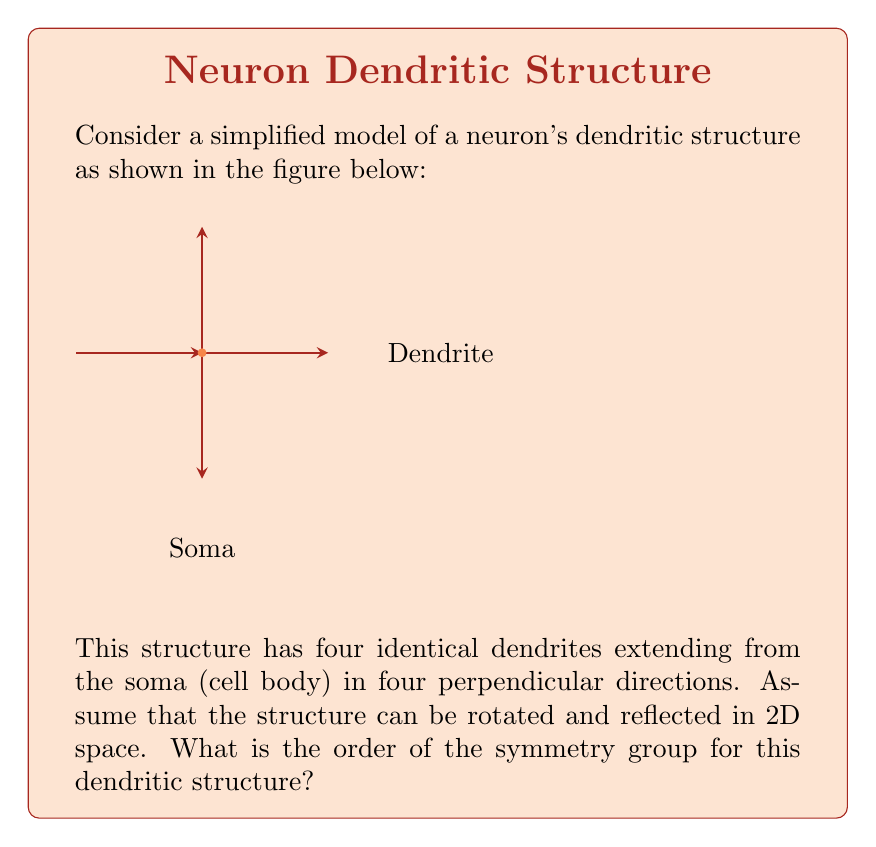Can you solve this math problem? To analyze the symmetry group of this dendritic structure, we need to consider all possible transformations that leave the structure unchanged. Let's approach this step-by-step:

1) Rotational symmetries:
   - The structure remains unchanged after rotations of 90°, 180°, 270°, and 360° (or 0°).
   - This gives us 4 rotational symmetries.

2) Reflection symmetries:
   - There are 4 lines of reflection: vertical, horizontal, and two diagonal lines.
   - This gives us 4 reflection symmetries.

3) Identity transformation:
   - The identity transformation (no change) is always a symmetry, but it's already counted in rotations (360° rotation).

Now, let's identify the symmetry group:

- This group of symmetries is known as the dihedral group of order 8, denoted as $D_4$ or $D_8$ (depending on the notation system).
- It contains 8 elements: 4 rotations and 4 reflections.

The group elements can be represented as:
$$D_4 = \{e, r, r^2, r^3, s, sr, sr^2, sr^3\}$$
where $e$ is the identity, $r$ is a 90° rotation, and $s$ is a reflection.

The order of a group is the number of elements in the group. Therefore, the order of the symmetry group for this dendritic structure is 8.
Answer: 8 